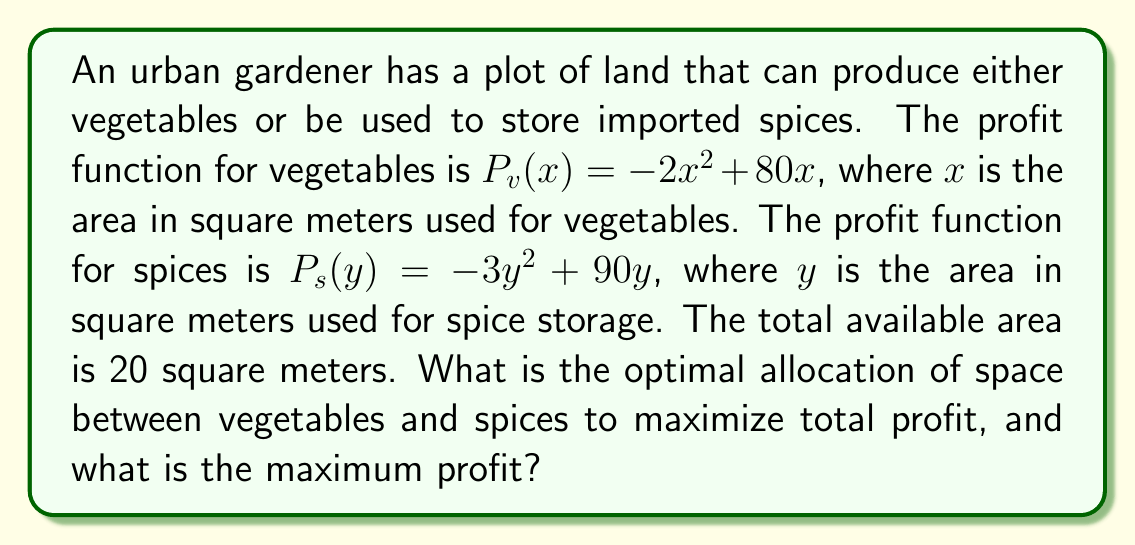Help me with this question. To solve this optimization problem, we need to follow these steps:

1) Let's define our objective function. The total profit $P$ is the sum of profits from vegetables and spices:

   $P = P_v(x) + P_s(y) = (-2x^2 + 80x) + (-3y^2 + 90y)$

2) We have a constraint that the total area is 20 square meters:

   $x + y = 20$

3) We can substitute $y = 20 - x$ into our profit function:

   $P = -2x^2 + 80x + (-3(20-x)^2 + 90(20-x))$
   $= -2x^2 + 80x + (-3(400-40x+x^2) + 1800 - 90x)$
   $= -2x^2 + 80x - 1200 + 120x - 3x^2 + 1800 - 90x$
   $= -5x^2 + 110x + 600$

4) Now we have a single-variable function to maximize. To find the maximum, we differentiate and set to zero:

   $\frac{dP}{dx} = -10x + 110 = 0$
   $10x = 110$
   $x = 11$

5) The second derivative is negative ($-10$), confirming this is a maximum.

6) Since $x = 11$, $y = 20 - 11 = 9$

7) To find the maximum profit, we substitute these values back into our original profit function:

   $P = (-2(11^2) + 80(11)) + (-3(9^2) + 90(9))$
   $= (-242 + 880) + (-243 + 810)$
   $= 638 + 567 = 1205$
Answer: The optimal allocation is 11 square meters for vegetables and 9 square meters for spices. The maximum profit is $1205. 